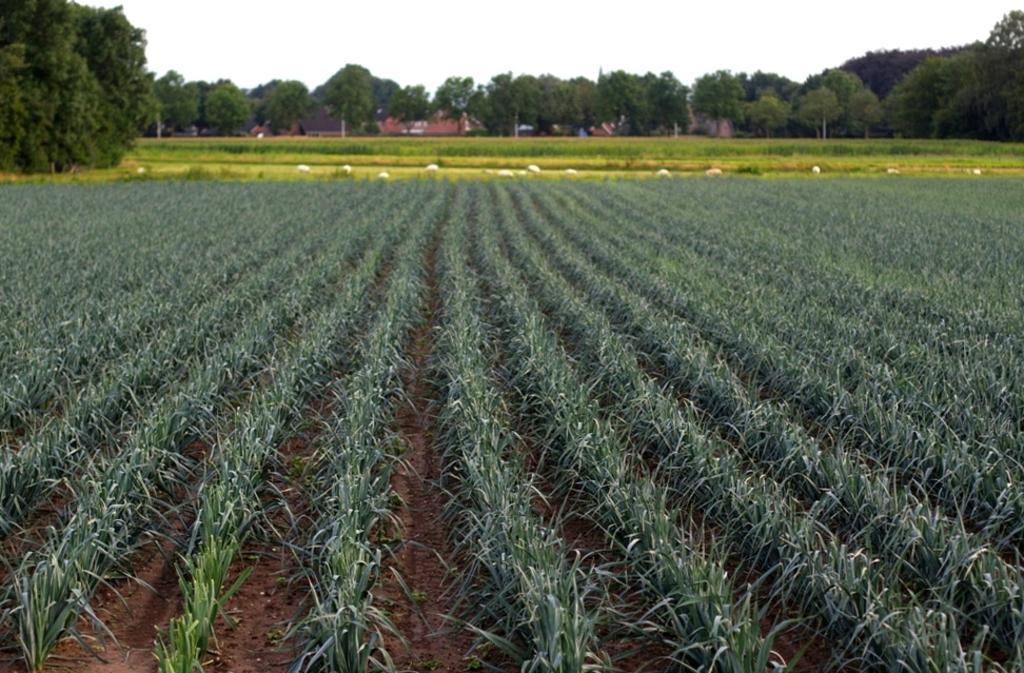Could you give a brief overview of what you see in this image? In this image there are few plants, trees, grass and a sky. 